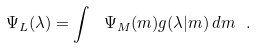<formula> <loc_0><loc_0><loc_500><loc_500>\Psi _ { L } ( \lambda ) = \int \ \Psi _ { M } ( m ) g ( \lambda | m ) \, d m \ .</formula> 